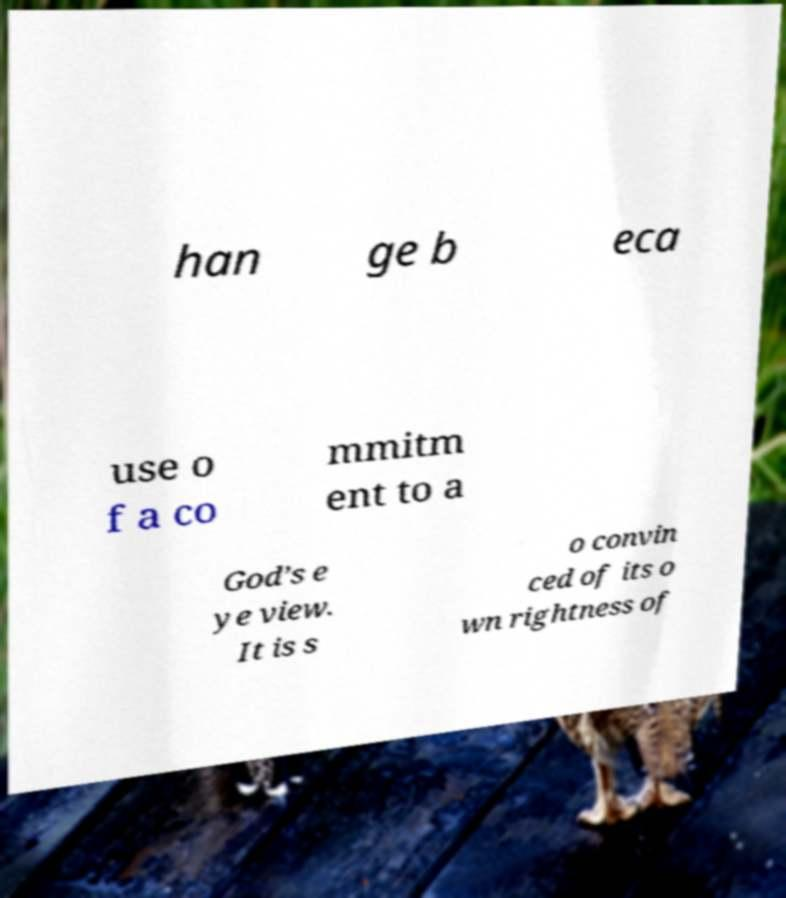Please identify and transcribe the text found in this image. han ge b eca use o f a co mmitm ent to a God’s e ye view. It is s o convin ced of its o wn rightness of 